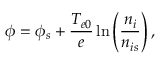Convert formula to latex. <formula><loc_0><loc_0><loc_500><loc_500>\phi = \phi _ { s } + \frac { T _ { e 0 } } { e } \ln \left ( \frac { n _ { i } } { n _ { i s } } \right ) ,</formula> 